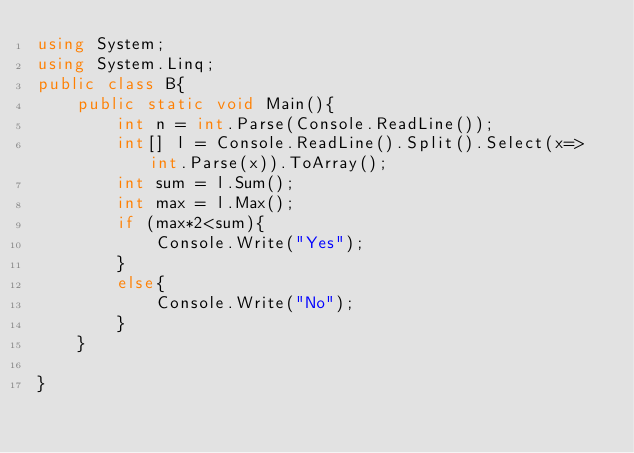Convert code to text. <code><loc_0><loc_0><loc_500><loc_500><_C#_>using System;
using System.Linq;
public class B{
    public static void Main(){
        int n = int.Parse(Console.ReadLine());
        int[] l = Console.ReadLine().Split().Select(x=>int.Parse(x)).ToArray();
        int sum = l.Sum();
        int max = l.Max();
        if (max*2<sum){
            Console.Write("Yes");
        }
        else{
            Console.Write("No");
        }
    }
            
}  
        
    

</code> 